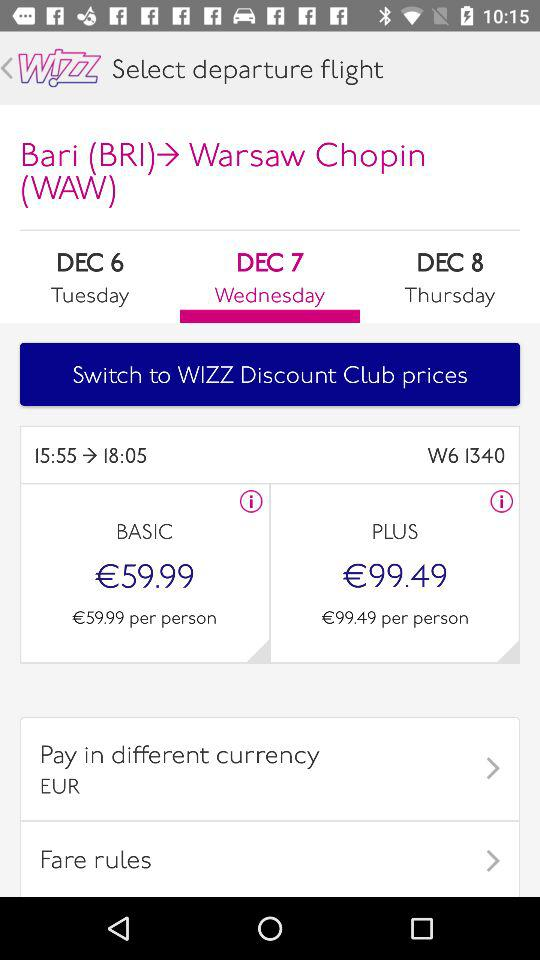Which date is selected for the departure flight? The date that is selected for the departure flight is Wednesday, December 7. 